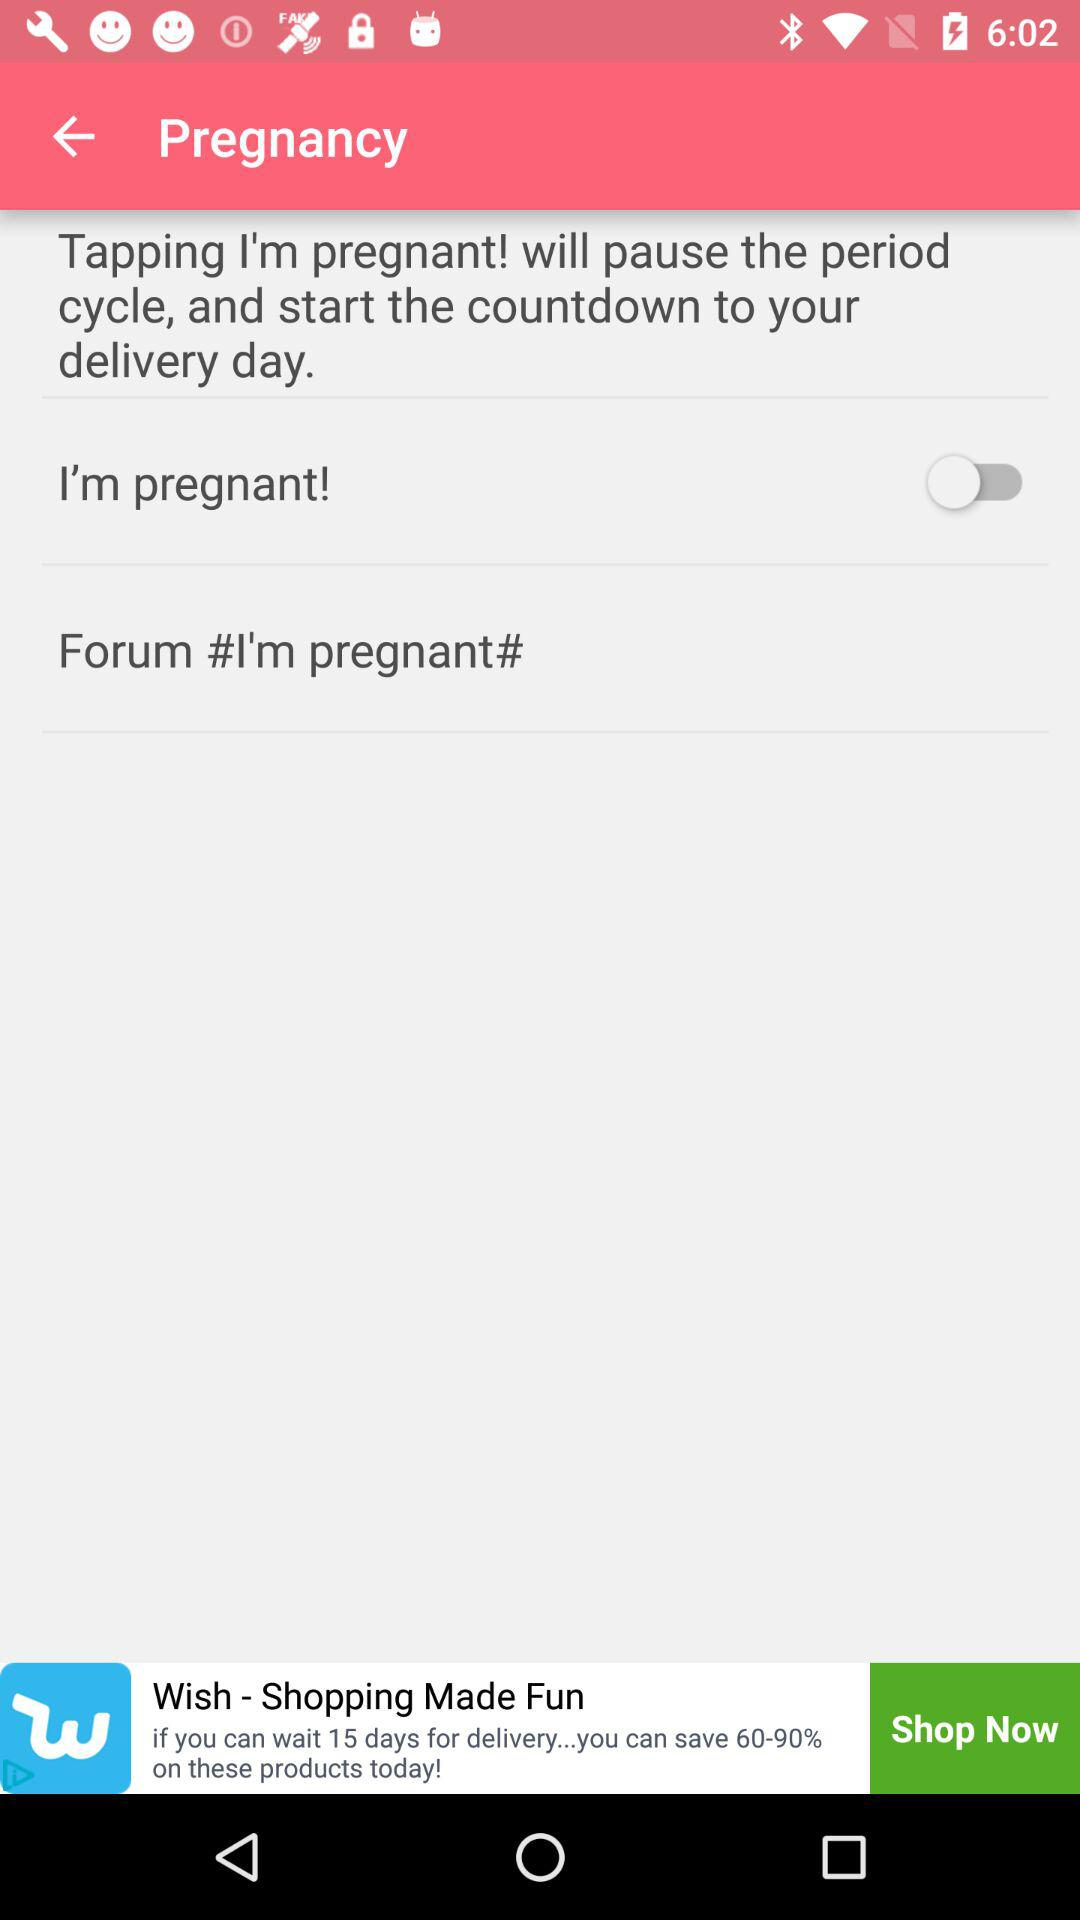What is the status of "I'm pregnant!"? The status is "off". 